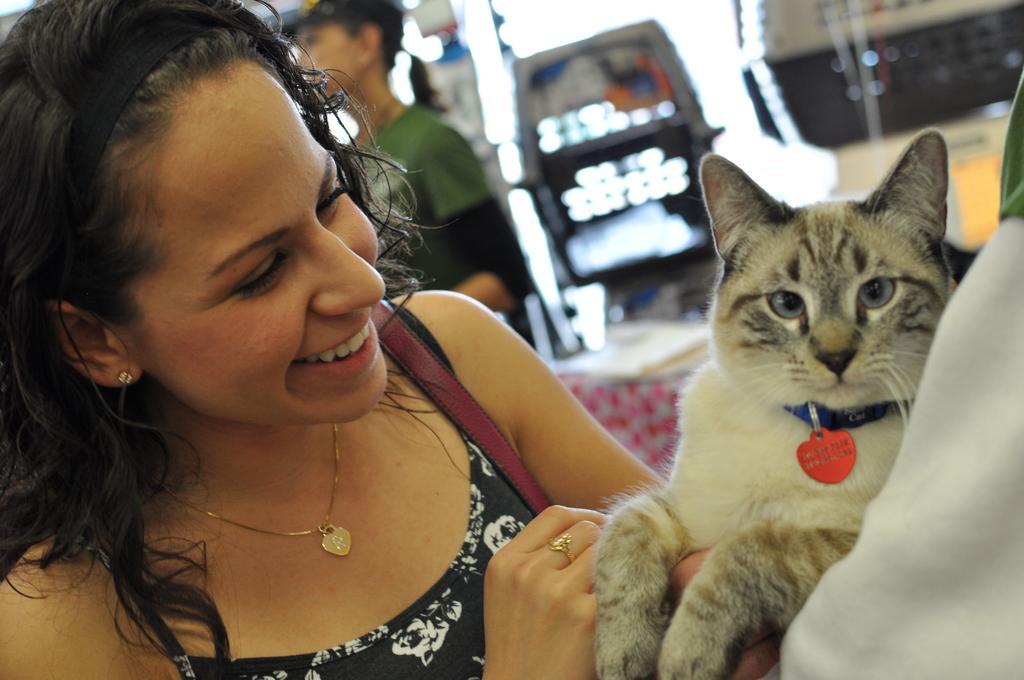Describe this image in one or two sentences. This is a picture taken in a room, the woman in black dress was holding a cat and to her right hand she is having a ring. Behind the woman there is other woman is standing on the floor and it is in blue. 